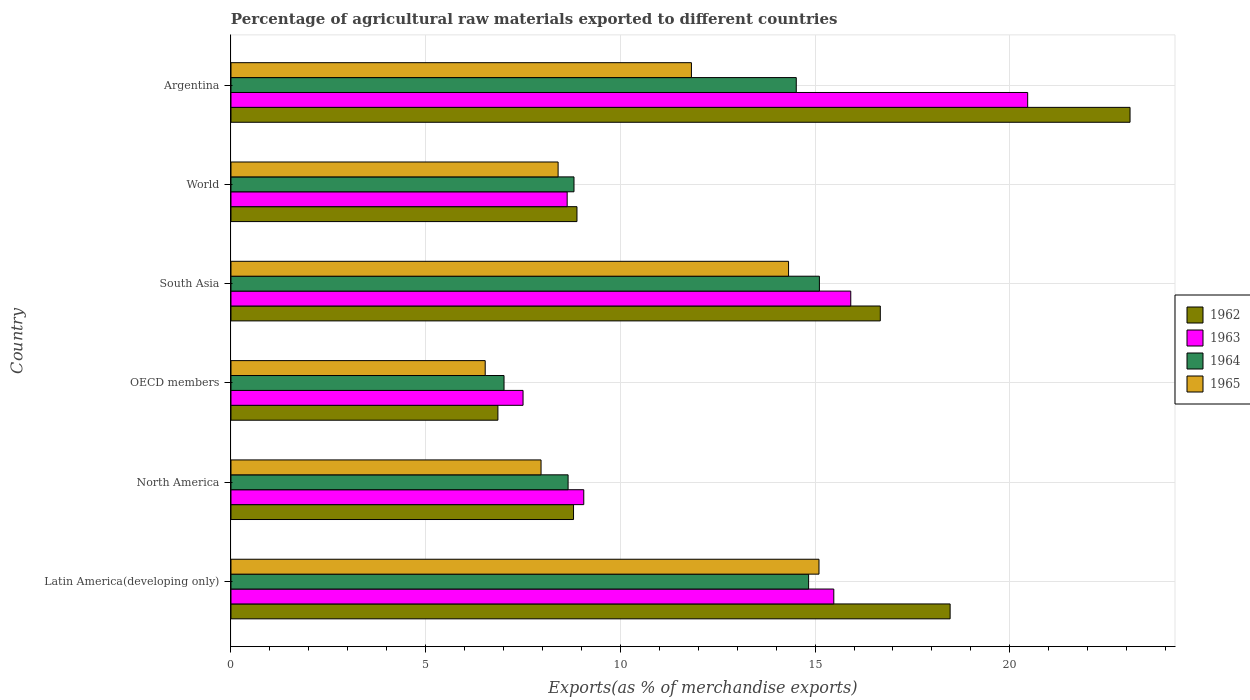How many groups of bars are there?
Ensure brevity in your answer.  6. Are the number of bars per tick equal to the number of legend labels?
Your answer should be very brief. Yes. How many bars are there on the 6th tick from the top?
Make the answer very short. 4. What is the label of the 6th group of bars from the top?
Provide a succinct answer. Latin America(developing only). What is the percentage of exports to different countries in 1965 in World?
Your answer should be very brief. 8.4. Across all countries, what is the maximum percentage of exports to different countries in 1962?
Give a very brief answer. 23.09. Across all countries, what is the minimum percentage of exports to different countries in 1965?
Keep it short and to the point. 6.53. In which country was the percentage of exports to different countries in 1962 maximum?
Make the answer very short. Argentina. In which country was the percentage of exports to different countries in 1964 minimum?
Your response must be concise. OECD members. What is the total percentage of exports to different countries in 1962 in the graph?
Provide a succinct answer. 82.77. What is the difference between the percentage of exports to different countries in 1964 in Argentina and that in South Asia?
Ensure brevity in your answer.  -0.59. What is the difference between the percentage of exports to different countries in 1962 in South Asia and the percentage of exports to different countries in 1963 in Argentina?
Provide a short and direct response. -3.78. What is the average percentage of exports to different countries in 1965 per country?
Make the answer very short. 10.69. What is the difference between the percentage of exports to different countries in 1965 and percentage of exports to different countries in 1962 in Latin America(developing only)?
Give a very brief answer. -3.37. What is the ratio of the percentage of exports to different countries in 1965 in Latin America(developing only) to that in North America?
Offer a terse response. 1.9. Is the percentage of exports to different countries in 1963 in Latin America(developing only) less than that in World?
Offer a terse response. No. What is the difference between the highest and the second highest percentage of exports to different countries in 1963?
Offer a terse response. 4.54. What is the difference between the highest and the lowest percentage of exports to different countries in 1965?
Provide a short and direct response. 8.57. In how many countries, is the percentage of exports to different countries in 1964 greater than the average percentage of exports to different countries in 1964 taken over all countries?
Offer a terse response. 3. Is the sum of the percentage of exports to different countries in 1964 in Latin America(developing only) and South Asia greater than the maximum percentage of exports to different countries in 1963 across all countries?
Give a very brief answer. Yes. Is it the case that in every country, the sum of the percentage of exports to different countries in 1963 and percentage of exports to different countries in 1962 is greater than the sum of percentage of exports to different countries in 1964 and percentage of exports to different countries in 1965?
Make the answer very short. No. What does the 3rd bar from the bottom in Latin America(developing only) represents?
Provide a short and direct response. 1964. Is it the case that in every country, the sum of the percentage of exports to different countries in 1964 and percentage of exports to different countries in 1965 is greater than the percentage of exports to different countries in 1962?
Keep it short and to the point. Yes. How many bars are there?
Your response must be concise. 24. Are all the bars in the graph horizontal?
Your answer should be very brief. Yes. What is the difference between two consecutive major ticks on the X-axis?
Ensure brevity in your answer.  5. Does the graph contain any zero values?
Your answer should be compact. No. Does the graph contain grids?
Make the answer very short. Yes. How many legend labels are there?
Your answer should be very brief. 4. How are the legend labels stacked?
Provide a succinct answer. Vertical. What is the title of the graph?
Give a very brief answer. Percentage of agricultural raw materials exported to different countries. Does "2001" appear as one of the legend labels in the graph?
Offer a terse response. No. What is the label or title of the X-axis?
Make the answer very short. Exports(as % of merchandise exports). What is the Exports(as % of merchandise exports) of 1962 in Latin America(developing only)?
Your answer should be compact. 18.47. What is the Exports(as % of merchandise exports) of 1963 in Latin America(developing only)?
Provide a succinct answer. 15.48. What is the Exports(as % of merchandise exports) in 1964 in Latin America(developing only)?
Your answer should be compact. 14.83. What is the Exports(as % of merchandise exports) in 1965 in Latin America(developing only)?
Make the answer very short. 15.1. What is the Exports(as % of merchandise exports) in 1962 in North America?
Give a very brief answer. 8.8. What is the Exports(as % of merchandise exports) of 1963 in North America?
Keep it short and to the point. 9.06. What is the Exports(as % of merchandise exports) of 1964 in North America?
Make the answer very short. 8.66. What is the Exports(as % of merchandise exports) of 1965 in North America?
Your answer should be very brief. 7.96. What is the Exports(as % of merchandise exports) in 1962 in OECD members?
Give a very brief answer. 6.85. What is the Exports(as % of merchandise exports) of 1963 in OECD members?
Give a very brief answer. 7.5. What is the Exports(as % of merchandise exports) in 1964 in OECD members?
Give a very brief answer. 7.01. What is the Exports(as % of merchandise exports) in 1965 in OECD members?
Make the answer very short. 6.53. What is the Exports(as % of merchandise exports) in 1962 in South Asia?
Keep it short and to the point. 16.67. What is the Exports(as % of merchandise exports) of 1963 in South Asia?
Keep it short and to the point. 15.92. What is the Exports(as % of merchandise exports) in 1964 in South Asia?
Offer a very short reply. 15.11. What is the Exports(as % of merchandise exports) in 1965 in South Asia?
Your answer should be compact. 14.32. What is the Exports(as % of merchandise exports) in 1962 in World?
Your response must be concise. 8.89. What is the Exports(as % of merchandise exports) in 1963 in World?
Offer a very short reply. 8.63. What is the Exports(as % of merchandise exports) in 1964 in World?
Offer a terse response. 8.81. What is the Exports(as % of merchandise exports) in 1965 in World?
Your response must be concise. 8.4. What is the Exports(as % of merchandise exports) in 1962 in Argentina?
Give a very brief answer. 23.09. What is the Exports(as % of merchandise exports) in 1963 in Argentina?
Provide a short and direct response. 20.46. What is the Exports(as % of merchandise exports) of 1964 in Argentina?
Provide a short and direct response. 14.52. What is the Exports(as % of merchandise exports) in 1965 in Argentina?
Your answer should be compact. 11.82. Across all countries, what is the maximum Exports(as % of merchandise exports) of 1962?
Keep it short and to the point. 23.09. Across all countries, what is the maximum Exports(as % of merchandise exports) of 1963?
Give a very brief answer. 20.46. Across all countries, what is the maximum Exports(as % of merchandise exports) in 1964?
Ensure brevity in your answer.  15.11. Across all countries, what is the maximum Exports(as % of merchandise exports) of 1965?
Offer a very short reply. 15.1. Across all countries, what is the minimum Exports(as % of merchandise exports) in 1962?
Provide a short and direct response. 6.85. Across all countries, what is the minimum Exports(as % of merchandise exports) of 1963?
Provide a short and direct response. 7.5. Across all countries, what is the minimum Exports(as % of merchandise exports) in 1964?
Give a very brief answer. 7.01. Across all countries, what is the minimum Exports(as % of merchandise exports) of 1965?
Make the answer very short. 6.53. What is the total Exports(as % of merchandise exports) of 1962 in the graph?
Make the answer very short. 82.77. What is the total Exports(as % of merchandise exports) in 1963 in the graph?
Provide a succinct answer. 77.05. What is the total Exports(as % of merchandise exports) of 1964 in the graph?
Give a very brief answer. 68.94. What is the total Exports(as % of merchandise exports) in 1965 in the graph?
Ensure brevity in your answer.  64.14. What is the difference between the Exports(as % of merchandise exports) in 1962 in Latin America(developing only) and that in North America?
Provide a short and direct response. 9.67. What is the difference between the Exports(as % of merchandise exports) in 1963 in Latin America(developing only) and that in North America?
Offer a very short reply. 6.42. What is the difference between the Exports(as % of merchandise exports) in 1964 in Latin America(developing only) and that in North America?
Ensure brevity in your answer.  6.18. What is the difference between the Exports(as % of merchandise exports) in 1965 in Latin America(developing only) and that in North America?
Keep it short and to the point. 7.14. What is the difference between the Exports(as % of merchandise exports) of 1962 in Latin America(developing only) and that in OECD members?
Your answer should be compact. 11.61. What is the difference between the Exports(as % of merchandise exports) of 1963 in Latin America(developing only) and that in OECD members?
Make the answer very short. 7.98. What is the difference between the Exports(as % of merchandise exports) in 1964 in Latin America(developing only) and that in OECD members?
Provide a succinct answer. 7.82. What is the difference between the Exports(as % of merchandise exports) of 1965 in Latin America(developing only) and that in OECD members?
Your response must be concise. 8.57. What is the difference between the Exports(as % of merchandise exports) of 1962 in Latin America(developing only) and that in South Asia?
Keep it short and to the point. 1.79. What is the difference between the Exports(as % of merchandise exports) of 1963 in Latin America(developing only) and that in South Asia?
Give a very brief answer. -0.44. What is the difference between the Exports(as % of merchandise exports) in 1964 in Latin America(developing only) and that in South Asia?
Make the answer very short. -0.28. What is the difference between the Exports(as % of merchandise exports) of 1965 in Latin America(developing only) and that in South Asia?
Make the answer very short. 0.78. What is the difference between the Exports(as % of merchandise exports) in 1962 in Latin America(developing only) and that in World?
Offer a terse response. 9.58. What is the difference between the Exports(as % of merchandise exports) in 1963 in Latin America(developing only) and that in World?
Make the answer very short. 6.85. What is the difference between the Exports(as % of merchandise exports) of 1964 in Latin America(developing only) and that in World?
Your answer should be very brief. 6.02. What is the difference between the Exports(as % of merchandise exports) in 1965 in Latin America(developing only) and that in World?
Make the answer very short. 6.7. What is the difference between the Exports(as % of merchandise exports) of 1962 in Latin America(developing only) and that in Argentina?
Your answer should be very brief. -4.62. What is the difference between the Exports(as % of merchandise exports) of 1963 in Latin America(developing only) and that in Argentina?
Ensure brevity in your answer.  -4.98. What is the difference between the Exports(as % of merchandise exports) in 1964 in Latin America(developing only) and that in Argentina?
Keep it short and to the point. 0.32. What is the difference between the Exports(as % of merchandise exports) in 1965 in Latin America(developing only) and that in Argentina?
Provide a short and direct response. 3.28. What is the difference between the Exports(as % of merchandise exports) in 1962 in North America and that in OECD members?
Give a very brief answer. 1.94. What is the difference between the Exports(as % of merchandise exports) in 1963 in North America and that in OECD members?
Provide a short and direct response. 1.56. What is the difference between the Exports(as % of merchandise exports) in 1964 in North America and that in OECD members?
Offer a very short reply. 1.65. What is the difference between the Exports(as % of merchandise exports) in 1965 in North America and that in OECD members?
Offer a very short reply. 1.43. What is the difference between the Exports(as % of merchandise exports) in 1962 in North America and that in South Asia?
Your response must be concise. -7.88. What is the difference between the Exports(as % of merchandise exports) in 1963 in North America and that in South Asia?
Ensure brevity in your answer.  -6.86. What is the difference between the Exports(as % of merchandise exports) in 1964 in North America and that in South Asia?
Your answer should be very brief. -6.45. What is the difference between the Exports(as % of merchandise exports) in 1965 in North America and that in South Asia?
Your answer should be compact. -6.36. What is the difference between the Exports(as % of merchandise exports) in 1962 in North America and that in World?
Make the answer very short. -0.09. What is the difference between the Exports(as % of merchandise exports) of 1963 in North America and that in World?
Make the answer very short. 0.43. What is the difference between the Exports(as % of merchandise exports) of 1964 in North America and that in World?
Your answer should be compact. -0.15. What is the difference between the Exports(as % of merchandise exports) in 1965 in North America and that in World?
Ensure brevity in your answer.  -0.44. What is the difference between the Exports(as % of merchandise exports) in 1962 in North America and that in Argentina?
Give a very brief answer. -14.29. What is the difference between the Exports(as % of merchandise exports) of 1963 in North America and that in Argentina?
Your answer should be very brief. -11.4. What is the difference between the Exports(as % of merchandise exports) in 1964 in North America and that in Argentina?
Provide a short and direct response. -5.86. What is the difference between the Exports(as % of merchandise exports) of 1965 in North America and that in Argentina?
Your answer should be very brief. -3.86. What is the difference between the Exports(as % of merchandise exports) in 1962 in OECD members and that in South Asia?
Offer a terse response. -9.82. What is the difference between the Exports(as % of merchandise exports) of 1963 in OECD members and that in South Asia?
Offer a very short reply. -8.42. What is the difference between the Exports(as % of merchandise exports) in 1964 in OECD members and that in South Asia?
Your answer should be compact. -8.1. What is the difference between the Exports(as % of merchandise exports) in 1965 in OECD members and that in South Asia?
Keep it short and to the point. -7.79. What is the difference between the Exports(as % of merchandise exports) in 1962 in OECD members and that in World?
Offer a terse response. -2.03. What is the difference between the Exports(as % of merchandise exports) of 1963 in OECD members and that in World?
Make the answer very short. -1.13. What is the difference between the Exports(as % of merchandise exports) of 1964 in OECD members and that in World?
Your answer should be compact. -1.8. What is the difference between the Exports(as % of merchandise exports) in 1965 in OECD members and that in World?
Offer a very short reply. -1.87. What is the difference between the Exports(as % of merchandise exports) of 1962 in OECD members and that in Argentina?
Provide a short and direct response. -16.23. What is the difference between the Exports(as % of merchandise exports) of 1963 in OECD members and that in Argentina?
Give a very brief answer. -12.96. What is the difference between the Exports(as % of merchandise exports) of 1964 in OECD members and that in Argentina?
Offer a terse response. -7.5. What is the difference between the Exports(as % of merchandise exports) of 1965 in OECD members and that in Argentina?
Offer a terse response. -5.3. What is the difference between the Exports(as % of merchandise exports) in 1962 in South Asia and that in World?
Keep it short and to the point. 7.79. What is the difference between the Exports(as % of merchandise exports) of 1963 in South Asia and that in World?
Offer a terse response. 7.28. What is the difference between the Exports(as % of merchandise exports) in 1964 in South Asia and that in World?
Make the answer very short. 6.3. What is the difference between the Exports(as % of merchandise exports) of 1965 in South Asia and that in World?
Provide a succinct answer. 5.92. What is the difference between the Exports(as % of merchandise exports) of 1962 in South Asia and that in Argentina?
Offer a very short reply. -6.41. What is the difference between the Exports(as % of merchandise exports) in 1963 in South Asia and that in Argentina?
Your answer should be very brief. -4.54. What is the difference between the Exports(as % of merchandise exports) of 1964 in South Asia and that in Argentina?
Offer a very short reply. 0.59. What is the difference between the Exports(as % of merchandise exports) in 1965 in South Asia and that in Argentina?
Offer a very short reply. 2.49. What is the difference between the Exports(as % of merchandise exports) of 1962 in World and that in Argentina?
Keep it short and to the point. -14.2. What is the difference between the Exports(as % of merchandise exports) in 1963 in World and that in Argentina?
Ensure brevity in your answer.  -11.83. What is the difference between the Exports(as % of merchandise exports) in 1964 in World and that in Argentina?
Offer a very short reply. -5.71. What is the difference between the Exports(as % of merchandise exports) of 1965 in World and that in Argentina?
Offer a terse response. -3.42. What is the difference between the Exports(as % of merchandise exports) of 1962 in Latin America(developing only) and the Exports(as % of merchandise exports) of 1963 in North America?
Give a very brief answer. 9.41. What is the difference between the Exports(as % of merchandise exports) in 1962 in Latin America(developing only) and the Exports(as % of merchandise exports) in 1964 in North America?
Your response must be concise. 9.81. What is the difference between the Exports(as % of merchandise exports) of 1962 in Latin America(developing only) and the Exports(as % of merchandise exports) of 1965 in North America?
Offer a very short reply. 10.51. What is the difference between the Exports(as % of merchandise exports) in 1963 in Latin America(developing only) and the Exports(as % of merchandise exports) in 1964 in North America?
Offer a very short reply. 6.82. What is the difference between the Exports(as % of merchandise exports) of 1963 in Latin America(developing only) and the Exports(as % of merchandise exports) of 1965 in North America?
Keep it short and to the point. 7.52. What is the difference between the Exports(as % of merchandise exports) of 1964 in Latin America(developing only) and the Exports(as % of merchandise exports) of 1965 in North America?
Your response must be concise. 6.87. What is the difference between the Exports(as % of merchandise exports) of 1962 in Latin America(developing only) and the Exports(as % of merchandise exports) of 1963 in OECD members?
Provide a short and direct response. 10.97. What is the difference between the Exports(as % of merchandise exports) in 1962 in Latin America(developing only) and the Exports(as % of merchandise exports) in 1964 in OECD members?
Provide a succinct answer. 11.46. What is the difference between the Exports(as % of merchandise exports) of 1962 in Latin America(developing only) and the Exports(as % of merchandise exports) of 1965 in OECD members?
Keep it short and to the point. 11.94. What is the difference between the Exports(as % of merchandise exports) of 1963 in Latin America(developing only) and the Exports(as % of merchandise exports) of 1964 in OECD members?
Provide a succinct answer. 8.47. What is the difference between the Exports(as % of merchandise exports) in 1963 in Latin America(developing only) and the Exports(as % of merchandise exports) in 1965 in OECD members?
Your answer should be compact. 8.95. What is the difference between the Exports(as % of merchandise exports) in 1964 in Latin America(developing only) and the Exports(as % of merchandise exports) in 1965 in OECD members?
Give a very brief answer. 8.31. What is the difference between the Exports(as % of merchandise exports) in 1962 in Latin America(developing only) and the Exports(as % of merchandise exports) in 1963 in South Asia?
Offer a very short reply. 2.55. What is the difference between the Exports(as % of merchandise exports) of 1962 in Latin America(developing only) and the Exports(as % of merchandise exports) of 1964 in South Asia?
Your response must be concise. 3.36. What is the difference between the Exports(as % of merchandise exports) in 1962 in Latin America(developing only) and the Exports(as % of merchandise exports) in 1965 in South Asia?
Give a very brief answer. 4.15. What is the difference between the Exports(as % of merchandise exports) in 1963 in Latin America(developing only) and the Exports(as % of merchandise exports) in 1964 in South Asia?
Make the answer very short. 0.37. What is the difference between the Exports(as % of merchandise exports) in 1963 in Latin America(developing only) and the Exports(as % of merchandise exports) in 1965 in South Asia?
Your answer should be very brief. 1.16. What is the difference between the Exports(as % of merchandise exports) of 1964 in Latin America(developing only) and the Exports(as % of merchandise exports) of 1965 in South Asia?
Provide a succinct answer. 0.51. What is the difference between the Exports(as % of merchandise exports) in 1962 in Latin America(developing only) and the Exports(as % of merchandise exports) in 1963 in World?
Provide a short and direct response. 9.83. What is the difference between the Exports(as % of merchandise exports) in 1962 in Latin America(developing only) and the Exports(as % of merchandise exports) in 1964 in World?
Offer a very short reply. 9.66. What is the difference between the Exports(as % of merchandise exports) in 1962 in Latin America(developing only) and the Exports(as % of merchandise exports) in 1965 in World?
Offer a very short reply. 10.07. What is the difference between the Exports(as % of merchandise exports) in 1963 in Latin America(developing only) and the Exports(as % of merchandise exports) in 1964 in World?
Your answer should be very brief. 6.67. What is the difference between the Exports(as % of merchandise exports) of 1963 in Latin America(developing only) and the Exports(as % of merchandise exports) of 1965 in World?
Give a very brief answer. 7.08. What is the difference between the Exports(as % of merchandise exports) of 1964 in Latin America(developing only) and the Exports(as % of merchandise exports) of 1965 in World?
Provide a succinct answer. 6.43. What is the difference between the Exports(as % of merchandise exports) in 1962 in Latin America(developing only) and the Exports(as % of merchandise exports) in 1963 in Argentina?
Provide a succinct answer. -1.99. What is the difference between the Exports(as % of merchandise exports) in 1962 in Latin America(developing only) and the Exports(as % of merchandise exports) in 1964 in Argentina?
Offer a very short reply. 3.95. What is the difference between the Exports(as % of merchandise exports) in 1962 in Latin America(developing only) and the Exports(as % of merchandise exports) in 1965 in Argentina?
Your answer should be compact. 6.64. What is the difference between the Exports(as % of merchandise exports) in 1963 in Latin America(developing only) and the Exports(as % of merchandise exports) in 1964 in Argentina?
Give a very brief answer. 0.96. What is the difference between the Exports(as % of merchandise exports) of 1963 in Latin America(developing only) and the Exports(as % of merchandise exports) of 1965 in Argentina?
Provide a short and direct response. 3.66. What is the difference between the Exports(as % of merchandise exports) in 1964 in Latin America(developing only) and the Exports(as % of merchandise exports) in 1965 in Argentina?
Your answer should be compact. 3.01. What is the difference between the Exports(as % of merchandise exports) in 1962 in North America and the Exports(as % of merchandise exports) in 1963 in OECD members?
Offer a terse response. 1.3. What is the difference between the Exports(as % of merchandise exports) of 1962 in North America and the Exports(as % of merchandise exports) of 1964 in OECD members?
Ensure brevity in your answer.  1.78. What is the difference between the Exports(as % of merchandise exports) in 1962 in North America and the Exports(as % of merchandise exports) in 1965 in OECD members?
Offer a terse response. 2.27. What is the difference between the Exports(as % of merchandise exports) in 1963 in North America and the Exports(as % of merchandise exports) in 1964 in OECD members?
Your answer should be compact. 2.05. What is the difference between the Exports(as % of merchandise exports) in 1963 in North America and the Exports(as % of merchandise exports) in 1965 in OECD members?
Provide a short and direct response. 2.53. What is the difference between the Exports(as % of merchandise exports) in 1964 in North America and the Exports(as % of merchandise exports) in 1965 in OECD members?
Your answer should be very brief. 2.13. What is the difference between the Exports(as % of merchandise exports) in 1962 in North America and the Exports(as % of merchandise exports) in 1963 in South Asia?
Your answer should be compact. -7.12. What is the difference between the Exports(as % of merchandise exports) of 1962 in North America and the Exports(as % of merchandise exports) of 1964 in South Asia?
Your answer should be very brief. -6.31. What is the difference between the Exports(as % of merchandise exports) of 1962 in North America and the Exports(as % of merchandise exports) of 1965 in South Asia?
Your response must be concise. -5.52. What is the difference between the Exports(as % of merchandise exports) in 1963 in North America and the Exports(as % of merchandise exports) in 1964 in South Asia?
Your answer should be compact. -6.05. What is the difference between the Exports(as % of merchandise exports) in 1963 in North America and the Exports(as % of merchandise exports) in 1965 in South Asia?
Your answer should be compact. -5.26. What is the difference between the Exports(as % of merchandise exports) in 1964 in North America and the Exports(as % of merchandise exports) in 1965 in South Asia?
Offer a very short reply. -5.66. What is the difference between the Exports(as % of merchandise exports) of 1962 in North America and the Exports(as % of merchandise exports) of 1963 in World?
Offer a very short reply. 0.16. What is the difference between the Exports(as % of merchandise exports) of 1962 in North America and the Exports(as % of merchandise exports) of 1964 in World?
Provide a succinct answer. -0.01. What is the difference between the Exports(as % of merchandise exports) of 1962 in North America and the Exports(as % of merchandise exports) of 1965 in World?
Your answer should be compact. 0.4. What is the difference between the Exports(as % of merchandise exports) in 1963 in North America and the Exports(as % of merchandise exports) in 1964 in World?
Ensure brevity in your answer.  0.25. What is the difference between the Exports(as % of merchandise exports) in 1963 in North America and the Exports(as % of merchandise exports) in 1965 in World?
Make the answer very short. 0.66. What is the difference between the Exports(as % of merchandise exports) in 1964 in North America and the Exports(as % of merchandise exports) in 1965 in World?
Your response must be concise. 0.26. What is the difference between the Exports(as % of merchandise exports) in 1962 in North America and the Exports(as % of merchandise exports) in 1963 in Argentina?
Provide a short and direct response. -11.66. What is the difference between the Exports(as % of merchandise exports) in 1962 in North America and the Exports(as % of merchandise exports) in 1964 in Argentina?
Make the answer very short. -5.72. What is the difference between the Exports(as % of merchandise exports) in 1962 in North America and the Exports(as % of merchandise exports) in 1965 in Argentina?
Offer a very short reply. -3.03. What is the difference between the Exports(as % of merchandise exports) in 1963 in North America and the Exports(as % of merchandise exports) in 1964 in Argentina?
Provide a short and direct response. -5.46. What is the difference between the Exports(as % of merchandise exports) in 1963 in North America and the Exports(as % of merchandise exports) in 1965 in Argentina?
Provide a short and direct response. -2.76. What is the difference between the Exports(as % of merchandise exports) in 1964 in North America and the Exports(as % of merchandise exports) in 1965 in Argentina?
Offer a very short reply. -3.17. What is the difference between the Exports(as % of merchandise exports) in 1962 in OECD members and the Exports(as % of merchandise exports) in 1963 in South Asia?
Your answer should be very brief. -9.06. What is the difference between the Exports(as % of merchandise exports) in 1962 in OECD members and the Exports(as % of merchandise exports) in 1964 in South Asia?
Your answer should be compact. -8.26. What is the difference between the Exports(as % of merchandise exports) in 1962 in OECD members and the Exports(as % of merchandise exports) in 1965 in South Asia?
Offer a terse response. -7.46. What is the difference between the Exports(as % of merchandise exports) of 1963 in OECD members and the Exports(as % of merchandise exports) of 1964 in South Asia?
Give a very brief answer. -7.61. What is the difference between the Exports(as % of merchandise exports) in 1963 in OECD members and the Exports(as % of merchandise exports) in 1965 in South Asia?
Ensure brevity in your answer.  -6.82. What is the difference between the Exports(as % of merchandise exports) of 1964 in OECD members and the Exports(as % of merchandise exports) of 1965 in South Asia?
Provide a short and direct response. -7.31. What is the difference between the Exports(as % of merchandise exports) in 1962 in OECD members and the Exports(as % of merchandise exports) in 1963 in World?
Offer a terse response. -1.78. What is the difference between the Exports(as % of merchandise exports) in 1962 in OECD members and the Exports(as % of merchandise exports) in 1964 in World?
Your answer should be very brief. -1.95. What is the difference between the Exports(as % of merchandise exports) in 1962 in OECD members and the Exports(as % of merchandise exports) in 1965 in World?
Offer a terse response. -1.55. What is the difference between the Exports(as % of merchandise exports) of 1963 in OECD members and the Exports(as % of merchandise exports) of 1964 in World?
Offer a terse response. -1.31. What is the difference between the Exports(as % of merchandise exports) of 1963 in OECD members and the Exports(as % of merchandise exports) of 1965 in World?
Your response must be concise. -0.9. What is the difference between the Exports(as % of merchandise exports) of 1964 in OECD members and the Exports(as % of merchandise exports) of 1965 in World?
Offer a very short reply. -1.39. What is the difference between the Exports(as % of merchandise exports) in 1962 in OECD members and the Exports(as % of merchandise exports) in 1963 in Argentina?
Your response must be concise. -13.6. What is the difference between the Exports(as % of merchandise exports) of 1962 in OECD members and the Exports(as % of merchandise exports) of 1964 in Argentina?
Ensure brevity in your answer.  -7.66. What is the difference between the Exports(as % of merchandise exports) in 1962 in OECD members and the Exports(as % of merchandise exports) in 1965 in Argentina?
Offer a very short reply. -4.97. What is the difference between the Exports(as % of merchandise exports) of 1963 in OECD members and the Exports(as % of merchandise exports) of 1964 in Argentina?
Your answer should be compact. -7.02. What is the difference between the Exports(as % of merchandise exports) of 1963 in OECD members and the Exports(as % of merchandise exports) of 1965 in Argentina?
Provide a short and direct response. -4.32. What is the difference between the Exports(as % of merchandise exports) in 1964 in OECD members and the Exports(as % of merchandise exports) in 1965 in Argentina?
Your answer should be compact. -4.81. What is the difference between the Exports(as % of merchandise exports) of 1962 in South Asia and the Exports(as % of merchandise exports) of 1963 in World?
Your response must be concise. 8.04. What is the difference between the Exports(as % of merchandise exports) of 1962 in South Asia and the Exports(as % of merchandise exports) of 1964 in World?
Your answer should be very brief. 7.87. What is the difference between the Exports(as % of merchandise exports) in 1962 in South Asia and the Exports(as % of merchandise exports) in 1965 in World?
Give a very brief answer. 8.27. What is the difference between the Exports(as % of merchandise exports) in 1963 in South Asia and the Exports(as % of merchandise exports) in 1964 in World?
Provide a short and direct response. 7.11. What is the difference between the Exports(as % of merchandise exports) in 1963 in South Asia and the Exports(as % of merchandise exports) in 1965 in World?
Provide a succinct answer. 7.52. What is the difference between the Exports(as % of merchandise exports) in 1964 in South Asia and the Exports(as % of merchandise exports) in 1965 in World?
Offer a very short reply. 6.71. What is the difference between the Exports(as % of merchandise exports) of 1962 in South Asia and the Exports(as % of merchandise exports) of 1963 in Argentina?
Make the answer very short. -3.78. What is the difference between the Exports(as % of merchandise exports) of 1962 in South Asia and the Exports(as % of merchandise exports) of 1964 in Argentina?
Your response must be concise. 2.16. What is the difference between the Exports(as % of merchandise exports) of 1962 in South Asia and the Exports(as % of merchandise exports) of 1965 in Argentina?
Your answer should be very brief. 4.85. What is the difference between the Exports(as % of merchandise exports) of 1963 in South Asia and the Exports(as % of merchandise exports) of 1964 in Argentina?
Ensure brevity in your answer.  1.4. What is the difference between the Exports(as % of merchandise exports) of 1963 in South Asia and the Exports(as % of merchandise exports) of 1965 in Argentina?
Your answer should be compact. 4.09. What is the difference between the Exports(as % of merchandise exports) in 1964 in South Asia and the Exports(as % of merchandise exports) in 1965 in Argentina?
Keep it short and to the point. 3.29. What is the difference between the Exports(as % of merchandise exports) in 1962 in World and the Exports(as % of merchandise exports) in 1963 in Argentina?
Your answer should be very brief. -11.57. What is the difference between the Exports(as % of merchandise exports) of 1962 in World and the Exports(as % of merchandise exports) of 1964 in Argentina?
Give a very brief answer. -5.63. What is the difference between the Exports(as % of merchandise exports) of 1962 in World and the Exports(as % of merchandise exports) of 1965 in Argentina?
Ensure brevity in your answer.  -2.94. What is the difference between the Exports(as % of merchandise exports) in 1963 in World and the Exports(as % of merchandise exports) in 1964 in Argentina?
Offer a terse response. -5.88. What is the difference between the Exports(as % of merchandise exports) in 1963 in World and the Exports(as % of merchandise exports) in 1965 in Argentina?
Give a very brief answer. -3.19. What is the difference between the Exports(as % of merchandise exports) of 1964 in World and the Exports(as % of merchandise exports) of 1965 in Argentina?
Provide a succinct answer. -3.02. What is the average Exports(as % of merchandise exports) in 1962 per country?
Keep it short and to the point. 13.79. What is the average Exports(as % of merchandise exports) in 1963 per country?
Make the answer very short. 12.84. What is the average Exports(as % of merchandise exports) in 1964 per country?
Provide a succinct answer. 11.49. What is the average Exports(as % of merchandise exports) of 1965 per country?
Your answer should be compact. 10.69. What is the difference between the Exports(as % of merchandise exports) of 1962 and Exports(as % of merchandise exports) of 1963 in Latin America(developing only)?
Make the answer very short. 2.99. What is the difference between the Exports(as % of merchandise exports) of 1962 and Exports(as % of merchandise exports) of 1964 in Latin America(developing only)?
Offer a terse response. 3.63. What is the difference between the Exports(as % of merchandise exports) of 1962 and Exports(as % of merchandise exports) of 1965 in Latin America(developing only)?
Provide a succinct answer. 3.37. What is the difference between the Exports(as % of merchandise exports) in 1963 and Exports(as % of merchandise exports) in 1964 in Latin America(developing only)?
Provide a succinct answer. 0.65. What is the difference between the Exports(as % of merchandise exports) of 1963 and Exports(as % of merchandise exports) of 1965 in Latin America(developing only)?
Your answer should be very brief. 0.38. What is the difference between the Exports(as % of merchandise exports) of 1964 and Exports(as % of merchandise exports) of 1965 in Latin America(developing only)?
Keep it short and to the point. -0.27. What is the difference between the Exports(as % of merchandise exports) of 1962 and Exports(as % of merchandise exports) of 1963 in North America?
Offer a very short reply. -0.26. What is the difference between the Exports(as % of merchandise exports) of 1962 and Exports(as % of merchandise exports) of 1964 in North America?
Your answer should be very brief. 0.14. What is the difference between the Exports(as % of merchandise exports) in 1962 and Exports(as % of merchandise exports) in 1965 in North America?
Offer a terse response. 0.83. What is the difference between the Exports(as % of merchandise exports) of 1963 and Exports(as % of merchandise exports) of 1964 in North America?
Offer a very short reply. 0.4. What is the difference between the Exports(as % of merchandise exports) in 1963 and Exports(as % of merchandise exports) in 1965 in North America?
Give a very brief answer. 1.1. What is the difference between the Exports(as % of merchandise exports) in 1964 and Exports(as % of merchandise exports) in 1965 in North America?
Provide a short and direct response. 0.69. What is the difference between the Exports(as % of merchandise exports) in 1962 and Exports(as % of merchandise exports) in 1963 in OECD members?
Offer a very short reply. -0.65. What is the difference between the Exports(as % of merchandise exports) of 1962 and Exports(as % of merchandise exports) of 1964 in OECD members?
Provide a succinct answer. -0.16. What is the difference between the Exports(as % of merchandise exports) in 1962 and Exports(as % of merchandise exports) in 1965 in OECD members?
Provide a short and direct response. 0.33. What is the difference between the Exports(as % of merchandise exports) in 1963 and Exports(as % of merchandise exports) in 1964 in OECD members?
Ensure brevity in your answer.  0.49. What is the difference between the Exports(as % of merchandise exports) in 1963 and Exports(as % of merchandise exports) in 1965 in OECD members?
Offer a terse response. 0.97. What is the difference between the Exports(as % of merchandise exports) of 1964 and Exports(as % of merchandise exports) of 1965 in OECD members?
Provide a succinct answer. 0.48. What is the difference between the Exports(as % of merchandise exports) of 1962 and Exports(as % of merchandise exports) of 1963 in South Asia?
Give a very brief answer. 0.76. What is the difference between the Exports(as % of merchandise exports) in 1962 and Exports(as % of merchandise exports) in 1964 in South Asia?
Make the answer very short. 1.56. What is the difference between the Exports(as % of merchandise exports) in 1962 and Exports(as % of merchandise exports) in 1965 in South Asia?
Make the answer very short. 2.36. What is the difference between the Exports(as % of merchandise exports) of 1963 and Exports(as % of merchandise exports) of 1964 in South Asia?
Provide a succinct answer. 0.81. What is the difference between the Exports(as % of merchandise exports) in 1963 and Exports(as % of merchandise exports) in 1965 in South Asia?
Provide a short and direct response. 1.6. What is the difference between the Exports(as % of merchandise exports) in 1964 and Exports(as % of merchandise exports) in 1965 in South Asia?
Make the answer very short. 0.79. What is the difference between the Exports(as % of merchandise exports) in 1962 and Exports(as % of merchandise exports) in 1963 in World?
Your answer should be compact. 0.25. What is the difference between the Exports(as % of merchandise exports) of 1962 and Exports(as % of merchandise exports) of 1964 in World?
Your response must be concise. 0.08. What is the difference between the Exports(as % of merchandise exports) in 1962 and Exports(as % of merchandise exports) in 1965 in World?
Offer a terse response. 0.48. What is the difference between the Exports(as % of merchandise exports) in 1963 and Exports(as % of merchandise exports) in 1964 in World?
Keep it short and to the point. -0.18. What is the difference between the Exports(as % of merchandise exports) in 1963 and Exports(as % of merchandise exports) in 1965 in World?
Your answer should be very brief. 0.23. What is the difference between the Exports(as % of merchandise exports) in 1964 and Exports(as % of merchandise exports) in 1965 in World?
Your answer should be very brief. 0.41. What is the difference between the Exports(as % of merchandise exports) in 1962 and Exports(as % of merchandise exports) in 1963 in Argentina?
Make the answer very short. 2.63. What is the difference between the Exports(as % of merchandise exports) of 1962 and Exports(as % of merchandise exports) of 1964 in Argentina?
Ensure brevity in your answer.  8.57. What is the difference between the Exports(as % of merchandise exports) of 1962 and Exports(as % of merchandise exports) of 1965 in Argentina?
Make the answer very short. 11.26. What is the difference between the Exports(as % of merchandise exports) of 1963 and Exports(as % of merchandise exports) of 1964 in Argentina?
Keep it short and to the point. 5.94. What is the difference between the Exports(as % of merchandise exports) of 1963 and Exports(as % of merchandise exports) of 1965 in Argentina?
Your answer should be compact. 8.63. What is the difference between the Exports(as % of merchandise exports) in 1964 and Exports(as % of merchandise exports) in 1965 in Argentina?
Your response must be concise. 2.69. What is the ratio of the Exports(as % of merchandise exports) in 1962 in Latin America(developing only) to that in North America?
Provide a short and direct response. 2.1. What is the ratio of the Exports(as % of merchandise exports) of 1963 in Latin America(developing only) to that in North America?
Offer a very short reply. 1.71. What is the ratio of the Exports(as % of merchandise exports) in 1964 in Latin America(developing only) to that in North America?
Offer a very short reply. 1.71. What is the ratio of the Exports(as % of merchandise exports) in 1965 in Latin America(developing only) to that in North America?
Your answer should be very brief. 1.9. What is the ratio of the Exports(as % of merchandise exports) of 1962 in Latin America(developing only) to that in OECD members?
Provide a succinct answer. 2.69. What is the ratio of the Exports(as % of merchandise exports) in 1963 in Latin America(developing only) to that in OECD members?
Provide a succinct answer. 2.06. What is the ratio of the Exports(as % of merchandise exports) in 1964 in Latin America(developing only) to that in OECD members?
Provide a succinct answer. 2.12. What is the ratio of the Exports(as % of merchandise exports) of 1965 in Latin America(developing only) to that in OECD members?
Make the answer very short. 2.31. What is the ratio of the Exports(as % of merchandise exports) in 1962 in Latin America(developing only) to that in South Asia?
Your response must be concise. 1.11. What is the ratio of the Exports(as % of merchandise exports) of 1963 in Latin America(developing only) to that in South Asia?
Provide a short and direct response. 0.97. What is the ratio of the Exports(as % of merchandise exports) in 1964 in Latin America(developing only) to that in South Asia?
Offer a terse response. 0.98. What is the ratio of the Exports(as % of merchandise exports) in 1965 in Latin America(developing only) to that in South Asia?
Provide a short and direct response. 1.05. What is the ratio of the Exports(as % of merchandise exports) in 1962 in Latin America(developing only) to that in World?
Offer a terse response. 2.08. What is the ratio of the Exports(as % of merchandise exports) of 1963 in Latin America(developing only) to that in World?
Your answer should be compact. 1.79. What is the ratio of the Exports(as % of merchandise exports) of 1964 in Latin America(developing only) to that in World?
Give a very brief answer. 1.68. What is the ratio of the Exports(as % of merchandise exports) of 1965 in Latin America(developing only) to that in World?
Offer a very short reply. 1.8. What is the ratio of the Exports(as % of merchandise exports) in 1962 in Latin America(developing only) to that in Argentina?
Offer a terse response. 0.8. What is the ratio of the Exports(as % of merchandise exports) in 1963 in Latin America(developing only) to that in Argentina?
Offer a terse response. 0.76. What is the ratio of the Exports(as % of merchandise exports) in 1964 in Latin America(developing only) to that in Argentina?
Offer a terse response. 1.02. What is the ratio of the Exports(as % of merchandise exports) in 1965 in Latin America(developing only) to that in Argentina?
Provide a short and direct response. 1.28. What is the ratio of the Exports(as % of merchandise exports) of 1962 in North America to that in OECD members?
Offer a very short reply. 1.28. What is the ratio of the Exports(as % of merchandise exports) of 1963 in North America to that in OECD members?
Offer a very short reply. 1.21. What is the ratio of the Exports(as % of merchandise exports) in 1964 in North America to that in OECD members?
Ensure brevity in your answer.  1.23. What is the ratio of the Exports(as % of merchandise exports) in 1965 in North America to that in OECD members?
Make the answer very short. 1.22. What is the ratio of the Exports(as % of merchandise exports) of 1962 in North America to that in South Asia?
Keep it short and to the point. 0.53. What is the ratio of the Exports(as % of merchandise exports) of 1963 in North America to that in South Asia?
Offer a terse response. 0.57. What is the ratio of the Exports(as % of merchandise exports) in 1964 in North America to that in South Asia?
Your response must be concise. 0.57. What is the ratio of the Exports(as % of merchandise exports) of 1965 in North America to that in South Asia?
Keep it short and to the point. 0.56. What is the ratio of the Exports(as % of merchandise exports) in 1963 in North America to that in World?
Your response must be concise. 1.05. What is the ratio of the Exports(as % of merchandise exports) in 1964 in North America to that in World?
Your answer should be compact. 0.98. What is the ratio of the Exports(as % of merchandise exports) in 1965 in North America to that in World?
Provide a succinct answer. 0.95. What is the ratio of the Exports(as % of merchandise exports) in 1962 in North America to that in Argentina?
Ensure brevity in your answer.  0.38. What is the ratio of the Exports(as % of merchandise exports) of 1963 in North America to that in Argentina?
Your answer should be very brief. 0.44. What is the ratio of the Exports(as % of merchandise exports) in 1964 in North America to that in Argentina?
Keep it short and to the point. 0.6. What is the ratio of the Exports(as % of merchandise exports) in 1965 in North America to that in Argentina?
Offer a very short reply. 0.67. What is the ratio of the Exports(as % of merchandise exports) in 1962 in OECD members to that in South Asia?
Your answer should be compact. 0.41. What is the ratio of the Exports(as % of merchandise exports) in 1963 in OECD members to that in South Asia?
Give a very brief answer. 0.47. What is the ratio of the Exports(as % of merchandise exports) of 1964 in OECD members to that in South Asia?
Make the answer very short. 0.46. What is the ratio of the Exports(as % of merchandise exports) in 1965 in OECD members to that in South Asia?
Provide a succinct answer. 0.46. What is the ratio of the Exports(as % of merchandise exports) in 1962 in OECD members to that in World?
Make the answer very short. 0.77. What is the ratio of the Exports(as % of merchandise exports) of 1963 in OECD members to that in World?
Ensure brevity in your answer.  0.87. What is the ratio of the Exports(as % of merchandise exports) of 1964 in OECD members to that in World?
Your answer should be very brief. 0.8. What is the ratio of the Exports(as % of merchandise exports) of 1965 in OECD members to that in World?
Make the answer very short. 0.78. What is the ratio of the Exports(as % of merchandise exports) in 1962 in OECD members to that in Argentina?
Make the answer very short. 0.3. What is the ratio of the Exports(as % of merchandise exports) of 1963 in OECD members to that in Argentina?
Ensure brevity in your answer.  0.37. What is the ratio of the Exports(as % of merchandise exports) of 1964 in OECD members to that in Argentina?
Ensure brevity in your answer.  0.48. What is the ratio of the Exports(as % of merchandise exports) of 1965 in OECD members to that in Argentina?
Provide a succinct answer. 0.55. What is the ratio of the Exports(as % of merchandise exports) of 1962 in South Asia to that in World?
Your answer should be very brief. 1.88. What is the ratio of the Exports(as % of merchandise exports) of 1963 in South Asia to that in World?
Make the answer very short. 1.84. What is the ratio of the Exports(as % of merchandise exports) in 1964 in South Asia to that in World?
Your answer should be very brief. 1.72. What is the ratio of the Exports(as % of merchandise exports) in 1965 in South Asia to that in World?
Your answer should be compact. 1.7. What is the ratio of the Exports(as % of merchandise exports) in 1962 in South Asia to that in Argentina?
Your response must be concise. 0.72. What is the ratio of the Exports(as % of merchandise exports) of 1963 in South Asia to that in Argentina?
Ensure brevity in your answer.  0.78. What is the ratio of the Exports(as % of merchandise exports) in 1964 in South Asia to that in Argentina?
Keep it short and to the point. 1.04. What is the ratio of the Exports(as % of merchandise exports) of 1965 in South Asia to that in Argentina?
Offer a very short reply. 1.21. What is the ratio of the Exports(as % of merchandise exports) of 1962 in World to that in Argentina?
Ensure brevity in your answer.  0.38. What is the ratio of the Exports(as % of merchandise exports) in 1963 in World to that in Argentina?
Keep it short and to the point. 0.42. What is the ratio of the Exports(as % of merchandise exports) in 1964 in World to that in Argentina?
Provide a short and direct response. 0.61. What is the ratio of the Exports(as % of merchandise exports) in 1965 in World to that in Argentina?
Make the answer very short. 0.71. What is the difference between the highest and the second highest Exports(as % of merchandise exports) in 1962?
Provide a short and direct response. 4.62. What is the difference between the highest and the second highest Exports(as % of merchandise exports) in 1963?
Provide a succinct answer. 4.54. What is the difference between the highest and the second highest Exports(as % of merchandise exports) in 1964?
Ensure brevity in your answer.  0.28. What is the difference between the highest and the second highest Exports(as % of merchandise exports) in 1965?
Provide a succinct answer. 0.78. What is the difference between the highest and the lowest Exports(as % of merchandise exports) of 1962?
Provide a short and direct response. 16.23. What is the difference between the highest and the lowest Exports(as % of merchandise exports) in 1963?
Provide a short and direct response. 12.96. What is the difference between the highest and the lowest Exports(as % of merchandise exports) in 1964?
Give a very brief answer. 8.1. What is the difference between the highest and the lowest Exports(as % of merchandise exports) in 1965?
Provide a succinct answer. 8.57. 